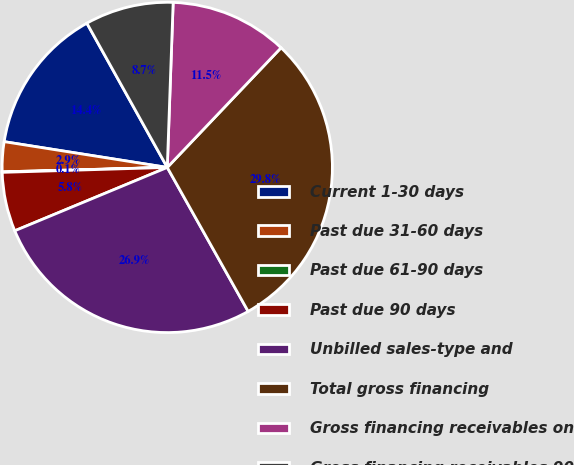Convert chart. <chart><loc_0><loc_0><loc_500><loc_500><pie_chart><fcel>Current 1-30 days<fcel>Past due 31-60 days<fcel>Past due 61-90 days<fcel>Past due 90 days<fcel>Unbilled sales-type and<fcel>Total gross financing<fcel>Gross financing receivables on<fcel>Gross financing receivables 90<nl><fcel>14.41%<fcel>2.92%<fcel>0.05%<fcel>5.79%<fcel>26.88%<fcel>29.75%<fcel>11.53%<fcel>8.66%<nl></chart> 